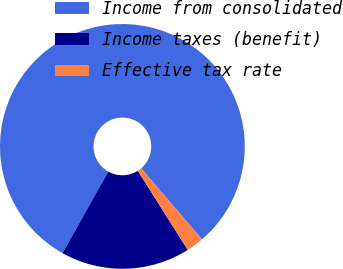Convert chart to OTSL. <chart><loc_0><loc_0><loc_500><loc_500><pie_chart><fcel>Income from consolidated<fcel>Income taxes (benefit)<fcel>Effective tax rate<nl><fcel>80.59%<fcel>17.1%<fcel>2.3%<nl></chart> 